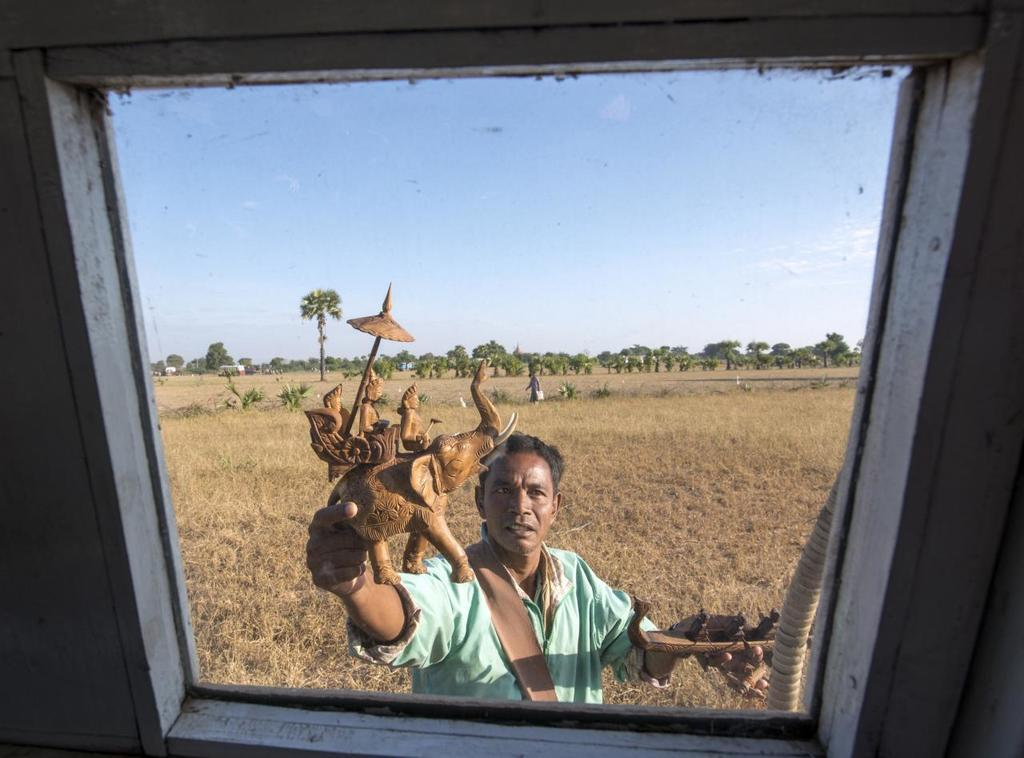What is the main subject of the image? There is a person standing in the image. What is the person holding in his hand? The person is holding a wooden toy in his hand. What can be seen in the background of the image? There are trees in the background of the image. What type of yak can be seen grazing in the background of the image? There is no yak present in the image; only the person and trees are visible in the background. Is there a lamp illuminating the person in the image? There is no lamp visible in the image. 